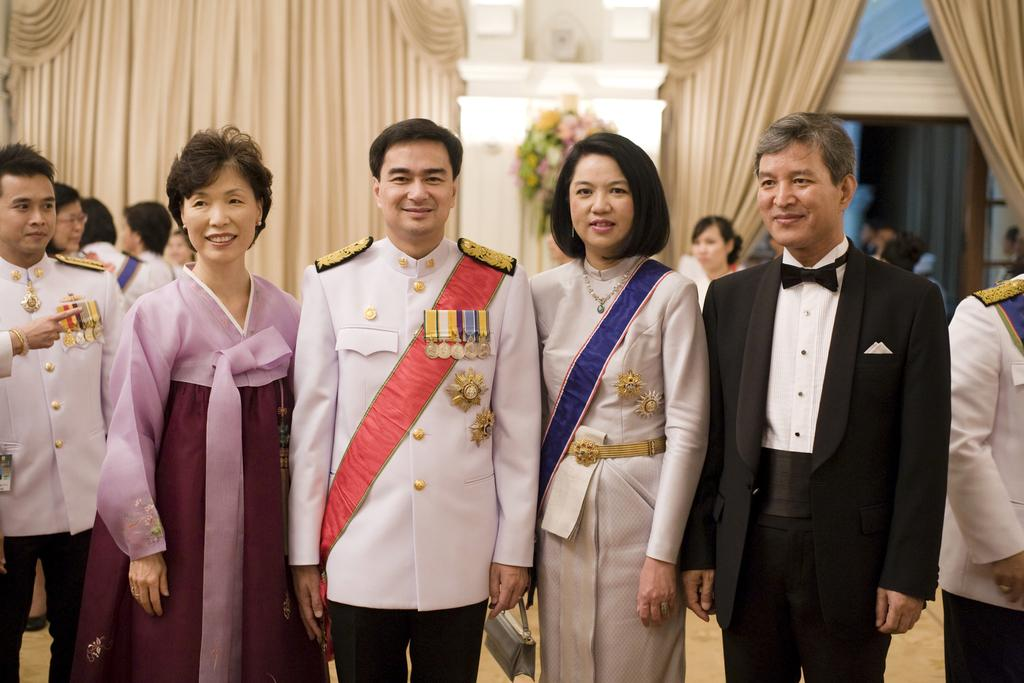What are the people in the center of the image doing? The people in the center of the image are standing and smiling. What can be seen in the background of the image? There is a wall, a flower bouquet, and curtains in the background of the image. Are there any other people visible in the image? Yes, there are additional people standing in the background of the image. How many quarters can be seen on the floor in the image? There are no quarters visible on the floor in the image. What type of maid is present in the image? There is no maid present in the image. 